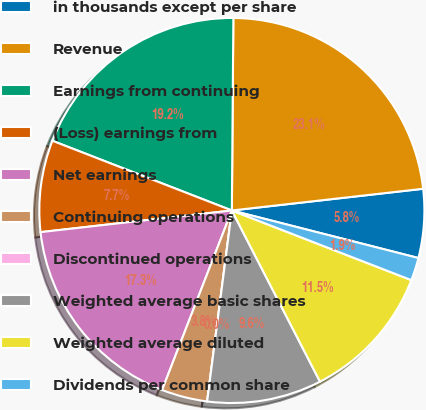Convert chart to OTSL. <chart><loc_0><loc_0><loc_500><loc_500><pie_chart><fcel>in thousands except per share<fcel>Revenue<fcel>Earnings from continuing<fcel>(Loss) earnings from<fcel>Net earnings<fcel>Continuing operations<fcel>Discontinued operations<fcel>Weighted average basic shares<fcel>Weighted average diluted<fcel>Dividends per common share<nl><fcel>5.77%<fcel>23.08%<fcel>19.23%<fcel>7.69%<fcel>17.31%<fcel>3.85%<fcel>0.0%<fcel>9.62%<fcel>11.54%<fcel>1.92%<nl></chart> 